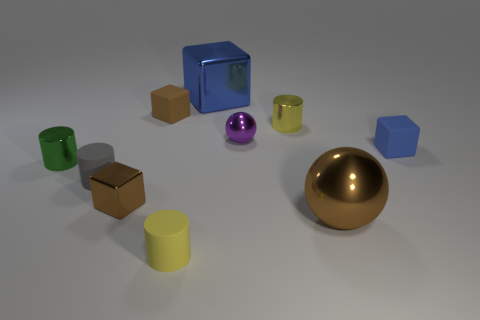How many small things are matte cubes or blue rubber objects?
Ensure brevity in your answer.  2. What number of things are cylinders to the right of the small green cylinder or blocks?
Offer a terse response. 7. Is the tiny metallic block the same color as the large shiny ball?
Make the answer very short. Yes. What number of other things are there of the same shape as the green thing?
Provide a short and direct response. 3. How many blue objects are either shiny cubes or tiny rubber things?
Your answer should be very brief. 2. What is the color of the large cube that is made of the same material as the green object?
Ensure brevity in your answer.  Blue. Does the small yellow cylinder behind the blue rubber object have the same material as the sphere that is in front of the purple shiny sphere?
Make the answer very short. Yes. The ball that is the same color as the tiny shiny block is what size?
Your answer should be compact. Large. What is the cylinder to the left of the gray thing made of?
Your response must be concise. Metal. There is a thing that is in front of the big brown metallic thing; does it have the same shape as the tiny yellow object that is behind the large brown thing?
Give a very brief answer. Yes. 